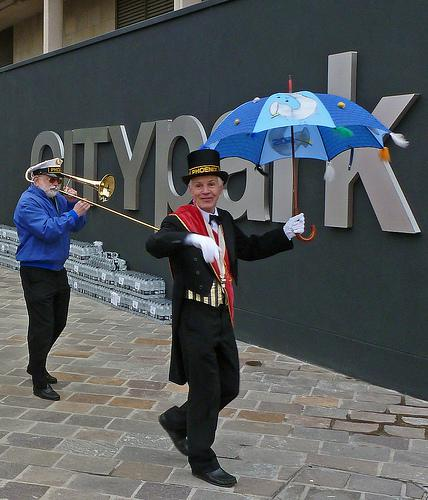Question: what color are the words?
Choices:
A. Silver.
B. Red.
C. Blue.
D. White.
Answer with the letter. Answer: A Question: how many guys are there?
Choices:
A. Three.
B. Two.
C. Four.
D. Five.
Answer with the letter. Answer: B Question: who is in the photo?
Choices:
A. Two guys.
B. A woman.
C. Two children.
D. An old man and woman.
Answer with the letter. Answer: A Question: where are the guys?
Choices:
A. At the city park.
B. At the beach.
C. At the rodeo.
D. At the outdoor concert.
Answer with the letter. Answer: A 